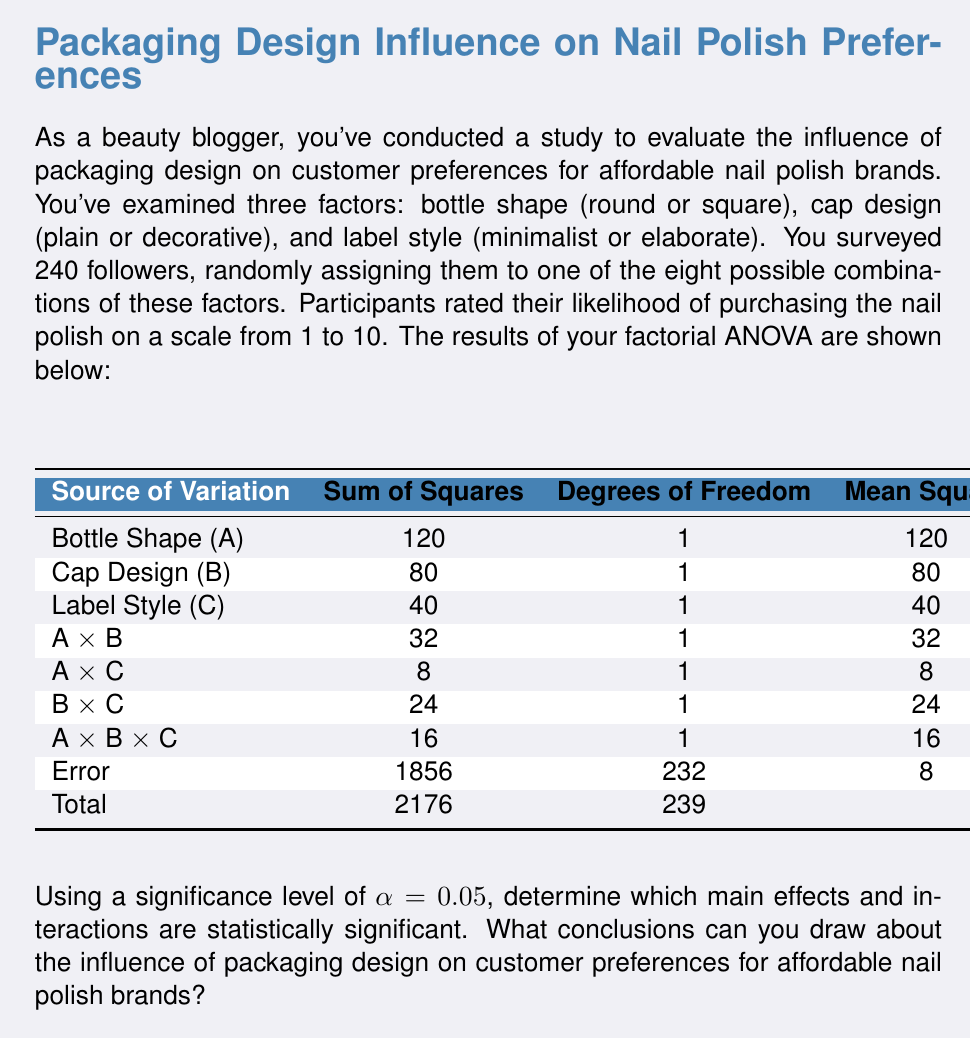Help me with this question. To determine which effects are statistically significant, we need to compare the F-values from the ANOVA table to the critical F-value. The degrees of freedom for the numerator (df₁) is 1 for all effects, and the degrees of freedom for the denominator (df₂) is 232 (the df for Error).

1. Find the critical F-value:
   Using an F-distribution table or calculator, we find:
   $F_{critical}(0.05, 1, 232) ≈ 3.88$

2. Compare each F-value to the critical F-value:
   - Bottle Shape (A): $F = 15 > 3.88$ (Significant)
   - Cap Design (B): $F = 10 > 3.88$ (Significant)
   - Label Style (C): $F = 5 > 3.88$ (Significant)
   - A × B interaction: $F = 4 > 3.88$ (Significant)
   - A × C interaction: $F = 1 < 3.88$ (Not significant)
   - B × C interaction: $F = 3 < 3.88$ (Not significant)
   - A × B × C interaction: $F = 2 < 3.88$ (Not significant)

3. Interpret the results:
   - All three main effects (Bottle Shape, Cap Design, and Label Style) are statistically significant, indicating that each factor independently influences customer preferences.
   - The interaction between Bottle Shape and Cap Design (A × B) is significant, suggesting that the effect of bottle shape on preference depends on the cap design, and vice versa.
   - The other interactions (A × C, B × C, and A × B × C) are not significant, meaning that these combinations of factors do not have a substantial impact on preferences beyond their individual effects.

4. Calculate effect sizes using partial eta-squared (η²):
   $η² = \frac{SS_{effect}}{SS_{effect} + SS_{error}}$

   - Bottle Shape: $η²_A = \frac{120}{120 + 1856} ≈ 0.061$
   - Cap Design: $η²_B = \frac{80}{80 + 1856} ≈ 0.041$
   - Label Style: $η²_C = \frac{40}{40 + 1856} ≈ 0.021$
   - A × B interaction: $η²_{A×B} = \frac{32}{32 + 1856} ≈ 0.017$

These effect sizes indicate that Bottle Shape has the largest impact on preferences, followed by Cap Design and Label Style. The A × B interaction has a relatively small effect.
Answer: The main effects of Bottle Shape, Cap Design, and Label Style, as well as the interaction between Bottle Shape and Cap Design, are statistically significant (p < 0.05). Bottle Shape has the largest effect on customer preferences (η² ≈ 0.061), followed by Cap Design (η² ≈ 0.041) and Label Style (η² ≈ 0.021). The significant interaction between Bottle Shape and Cap Design (η² ≈ 0.017) suggests that the impact of one factor depends on the level of the other. Other interactions are not significant. These findings indicate that packaging design elements significantly influence customer preferences for affordable nail polish brands, with bottle shape being the most important factor. 